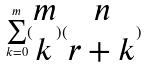Convert formula to latex. <formula><loc_0><loc_0><loc_500><loc_500>\sum _ { k = 0 } ^ { m } ( \begin{matrix} m \\ k \end{matrix} ) ( \begin{matrix} n \\ r + k \end{matrix} )</formula> 